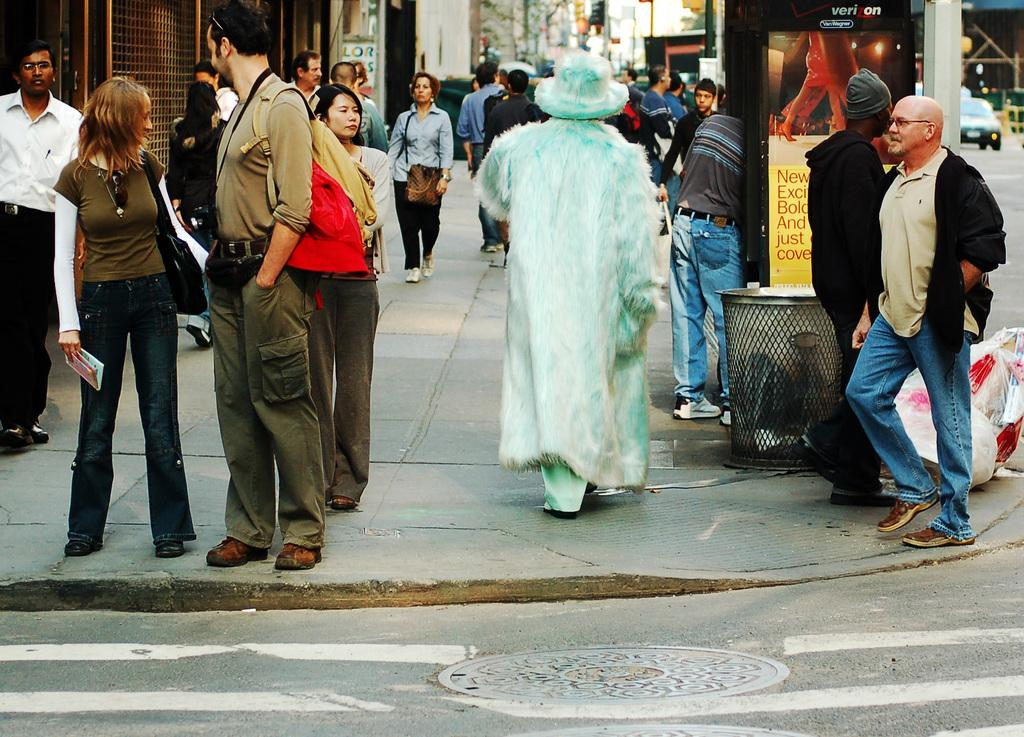How many people can be seen in the image? There are people in the image, but the exact number cannot be determined from the provided facts. What is located in the foreground area of the image? There is a trash bin and a poster in the foreground area of the image. What can be seen in the background of the image? There are stalls, buildings, trees, poles, and a vehicle in the background of the image. What type of plant is growing on the spring in the image? There is no plant or spring present in the image. How many tickets are visible in the image? There is no mention of tickets in the provided facts, so it cannot be determined if any are visible in the image. 